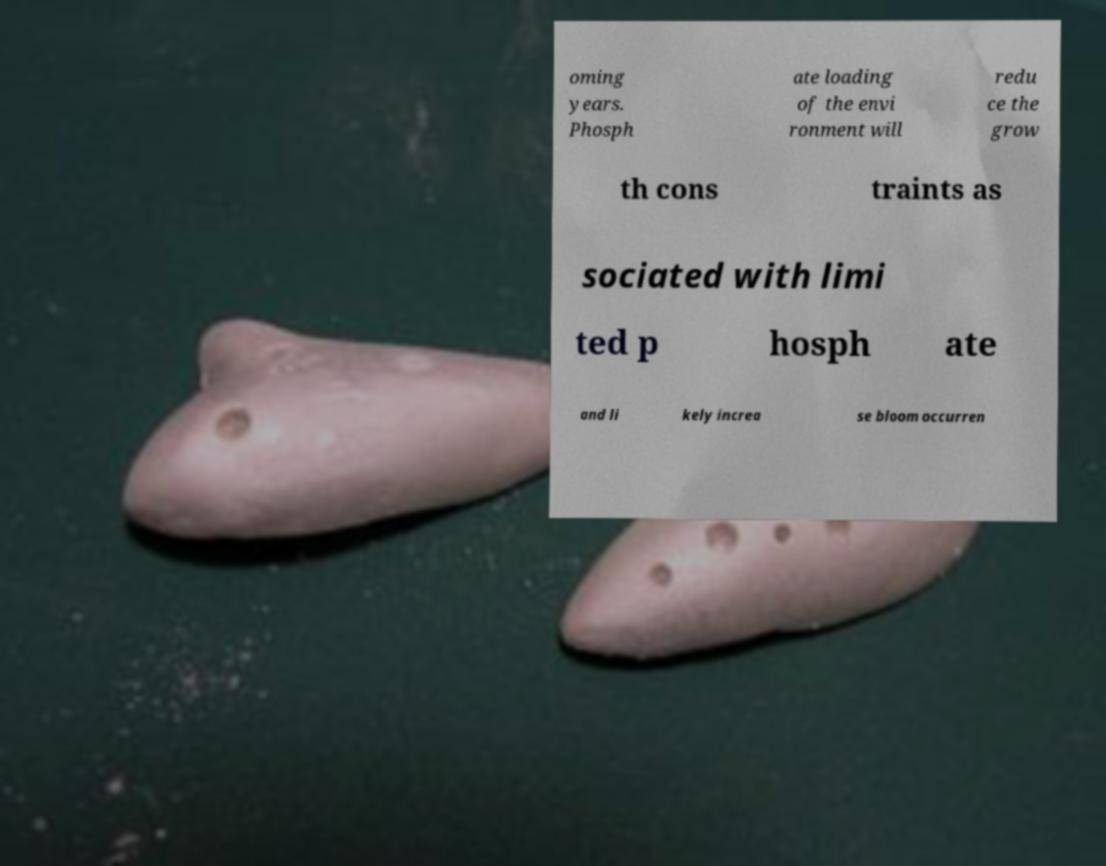Can you read and provide the text displayed in the image?This photo seems to have some interesting text. Can you extract and type it out for me? oming years. Phosph ate loading of the envi ronment will redu ce the grow th cons traints as sociated with limi ted p hosph ate and li kely increa se bloom occurren 